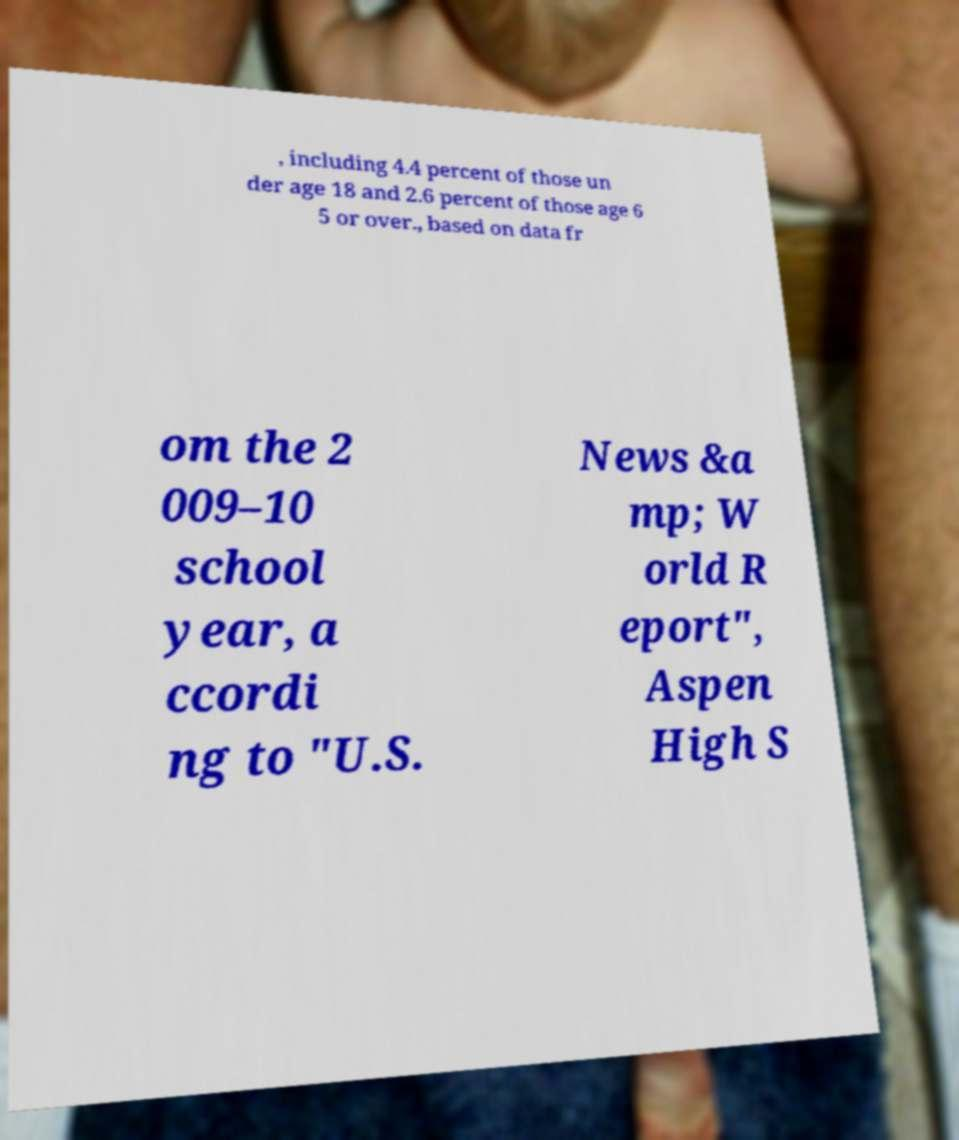Could you assist in decoding the text presented in this image and type it out clearly? , including 4.4 percent of those un der age 18 and 2.6 percent of those age 6 5 or over., based on data fr om the 2 009–10 school year, a ccordi ng to "U.S. News &a mp; W orld R eport", Aspen High S 